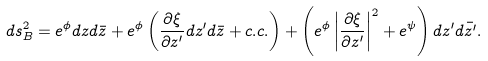Convert formula to latex. <formula><loc_0><loc_0><loc_500><loc_500>d s ^ { 2 } _ { B } = e ^ { \phi } d z d \bar { z } + e ^ { \phi } \left ( \frac { \partial \xi } { \partial z ^ { \prime } } d z ^ { \prime } d \bar { z } + c . c . \right ) + \left ( e ^ { \phi } \left | \frac { \partial \xi } { \partial z ^ { \prime } } \right | ^ { 2 } + e ^ { \psi } \right ) d z ^ { \prime } d \bar { z ^ { \prime } } .</formula> 